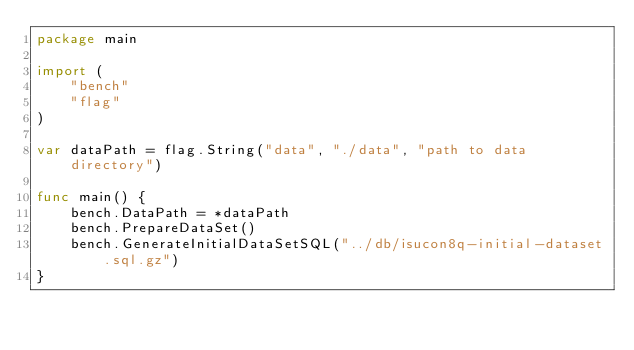Convert code to text. <code><loc_0><loc_0><loc_500><loc_500><_Go_>package main

import (
	"bench"
	"flag"
)

var dataPath = flag.String("data", "./data", "path to data directory")

func main() {
	bench.DataPath = *dataPath
	bench.PrepareDataSet()
	bench.GenerateInitialDataSetSQL("../db/isucon8q-initial-dataset.sql.gz")
}
</code> 